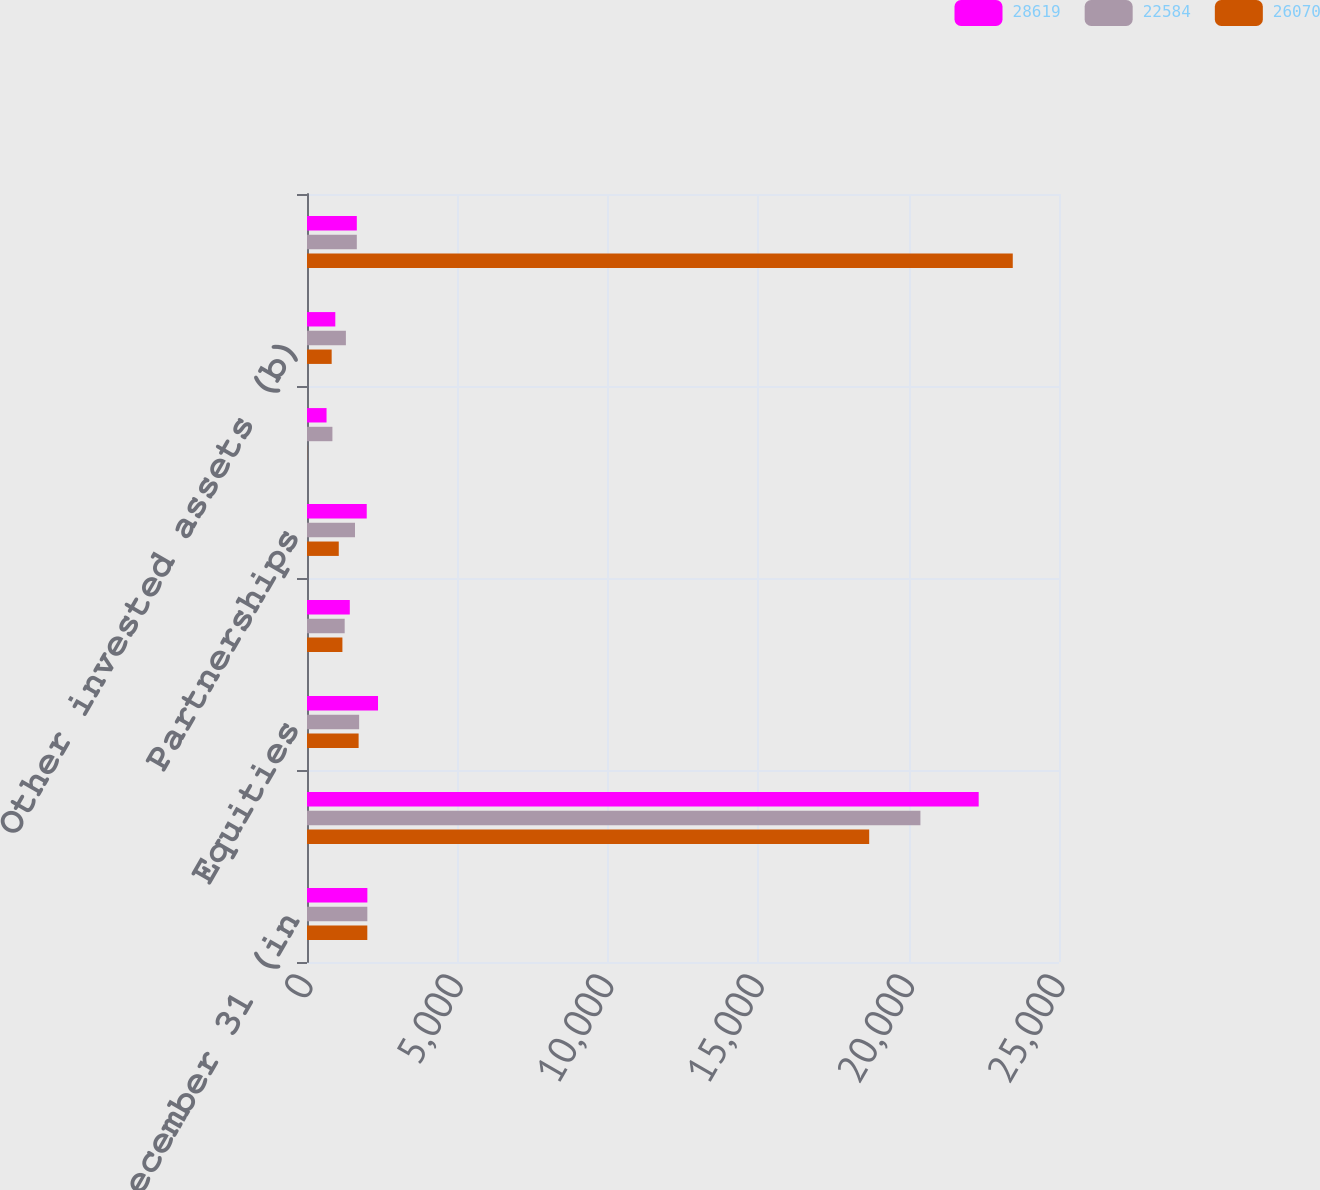<chart> <loc_0><loc_0><loc_500><loc_500><stacked_bar_chart><ecel><fcel>Years Ended December 31 (in<fcel>Fixed maturities (a)<fcel>Equities<fcel>Interest on mortgage and other<fcel>Partnerships<fcel>Mutual funds<fcel>Other invested assets (b)<fcel>Total investment income<nl><fcel>28619<fcel>2007<fcel>22330<fcel>2361<fcel>1423<fcel>1986<fcel>650<fcel>941<fcel>1656<nl><fcel>22584<fcel>2006<fcel>20393<fcel>1733<fcel>1253<fcel>1596<fcel>845<fcel>1293<fcel>1656<nl><fcel>26070<fcel>2005<fcel>18690<fcel>1716<fcel>1177<fcel>1056<fcel>4<fcel>820<fcel>23463<nl></chart> 